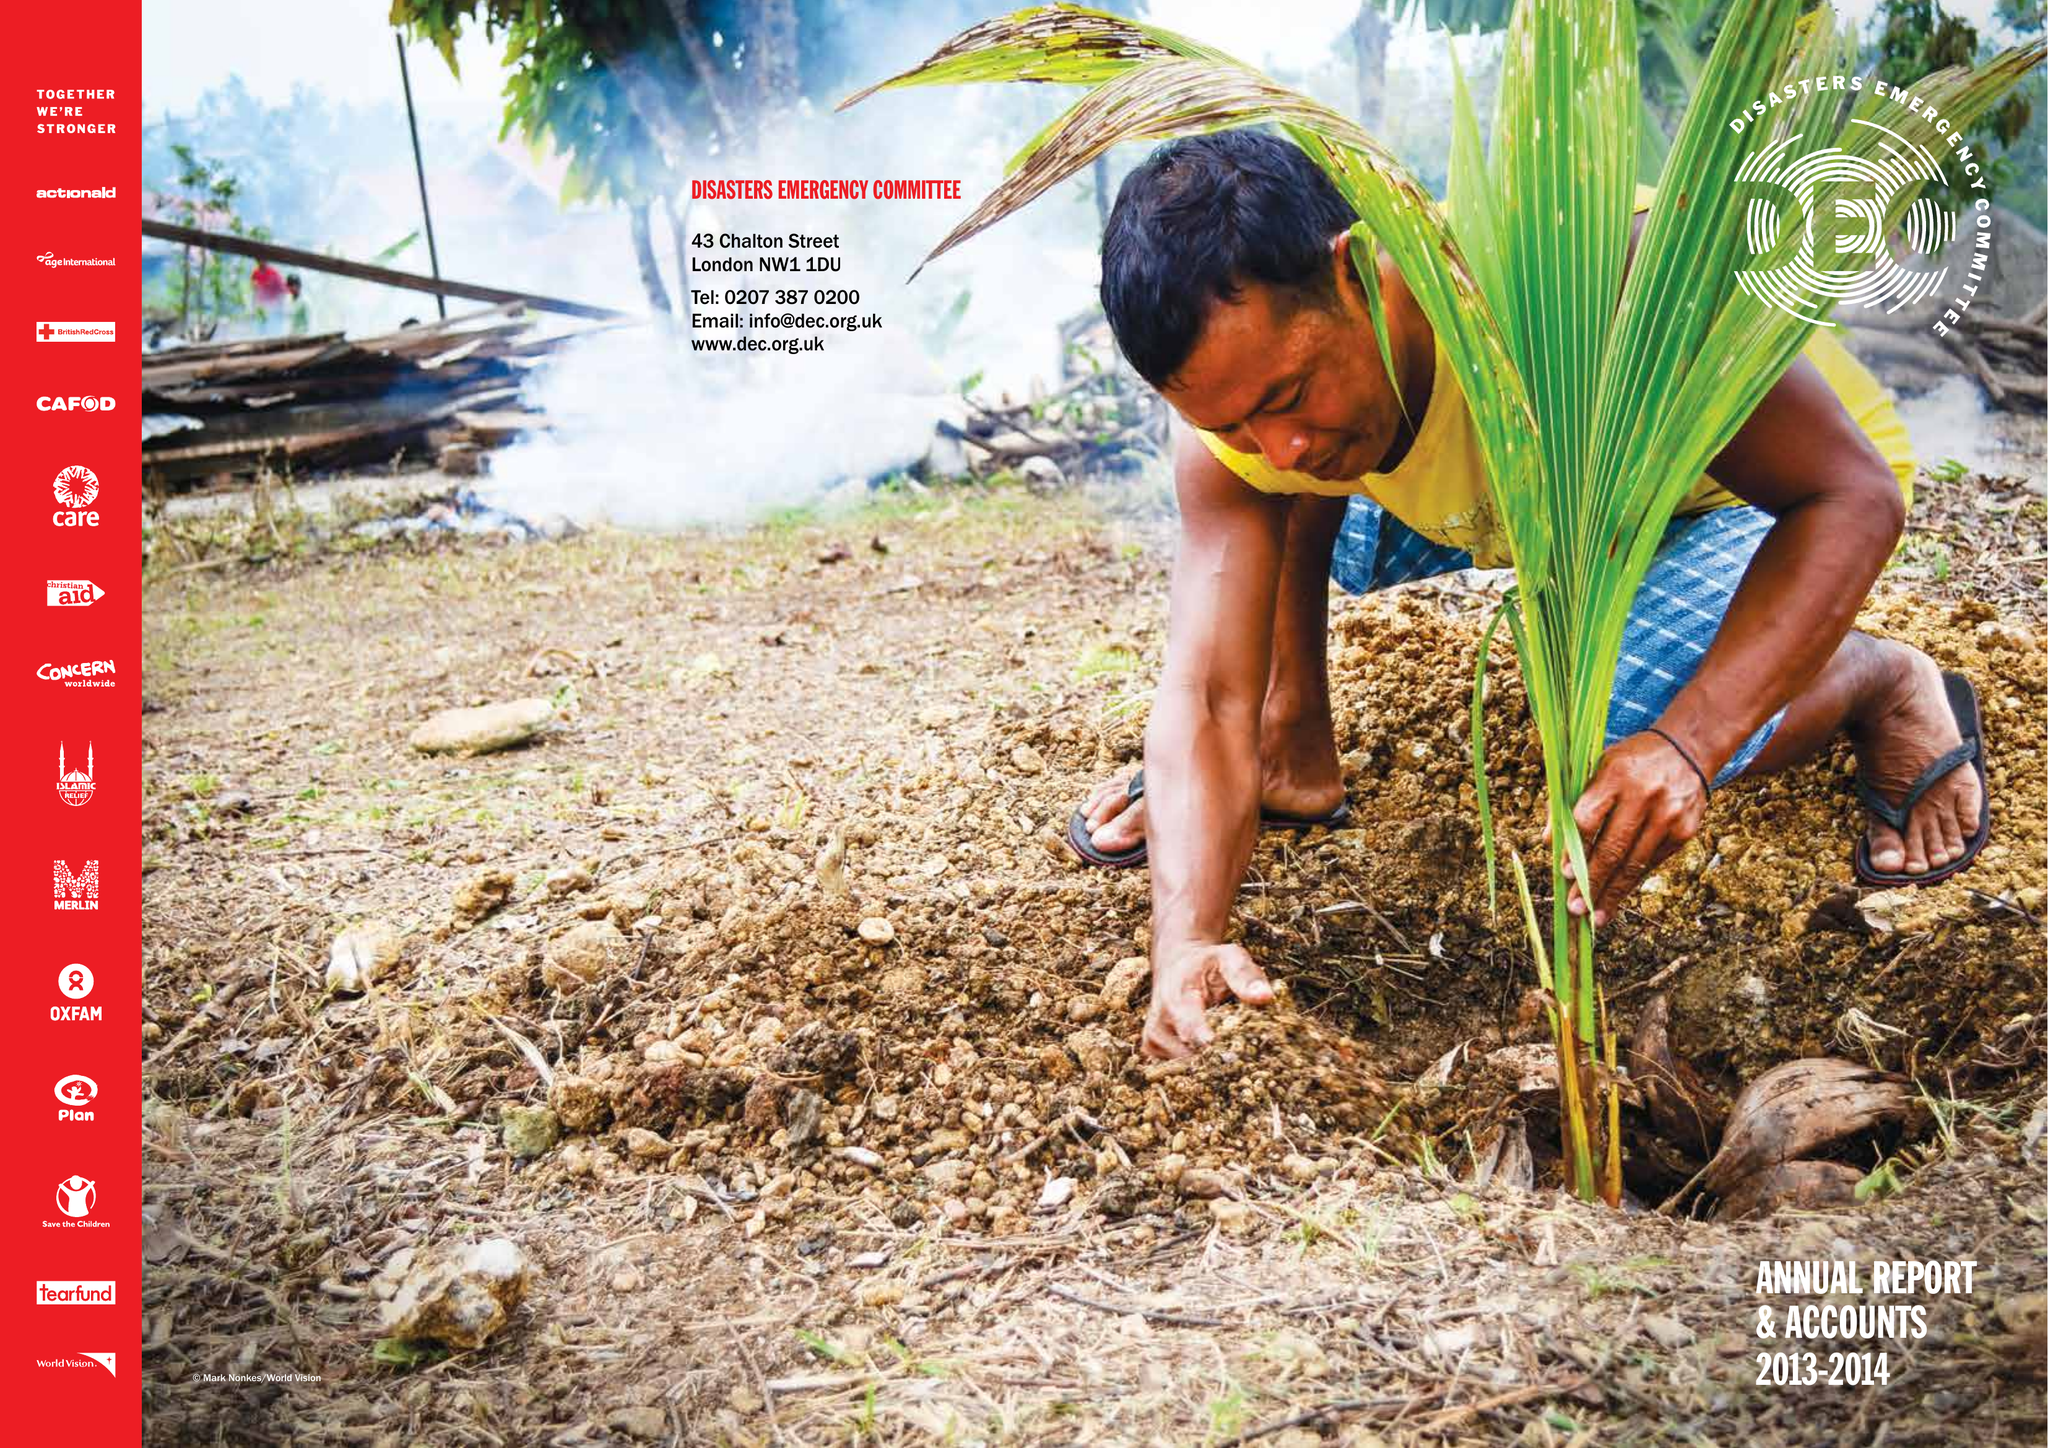What is the value for the report_date?
Answer the question using a single word or phrase. 2014-03-31 